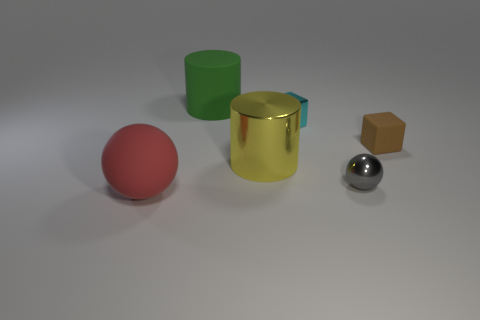What materials are the objects in this image made of? The objects in the image appear to have various materials. The sphere in the front is red rubber, the sphere in the back looks like polished chrome or metal, the cylinder is gold and has a shiny metallic finish, the small object to the right seems to be a tiny brown box which might be made of cardboard or wood, and the object on the far left looks like a green plastic cylinder. 